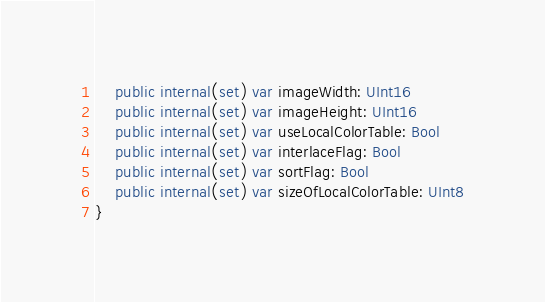Convert code to text. <code><loc_0><loc_0><loc_500><loc_500><_Swift_>    public internal(set) var imageWidth: UInt16
    public internal(set) var imageHeight: UInt16
    public internal(set) var useLocalColorTable: Bool
    public internal(set) var interlaceFlag: Bool
    public internal(set) var sortFlag: Bool
    public internal(set) var sizeOfLocalColorTable: UInt8
}
</code> 